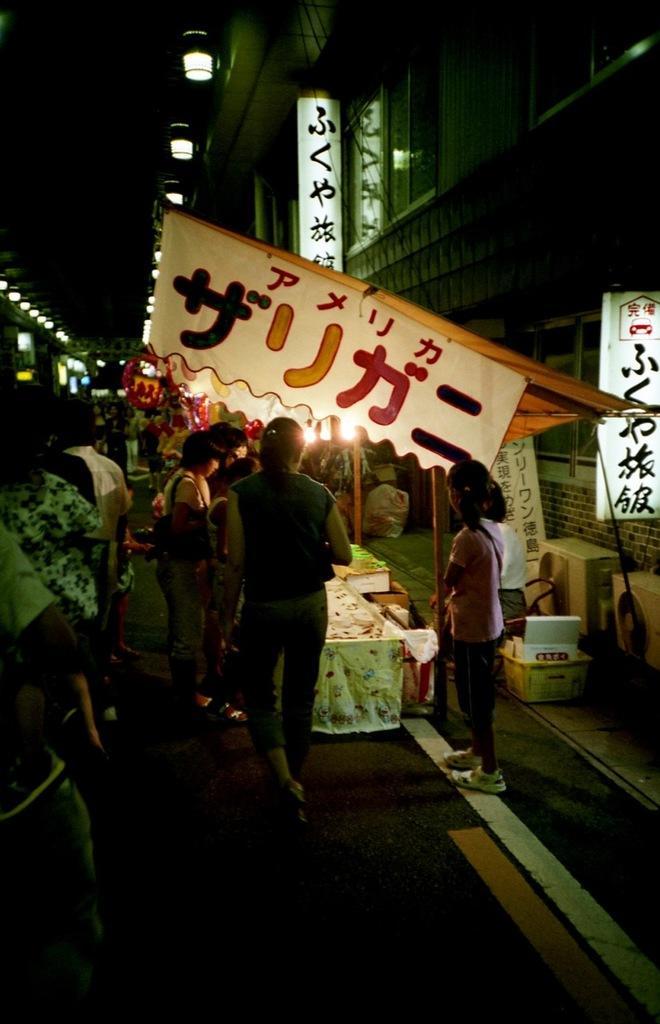In one or two sentences, can you explain what this image depicts? In this image I see number of people and I see the lights over here and I see the boards and banners on which there is something written and I see the path. In the background I see the lights and I see that it is dark over here. 